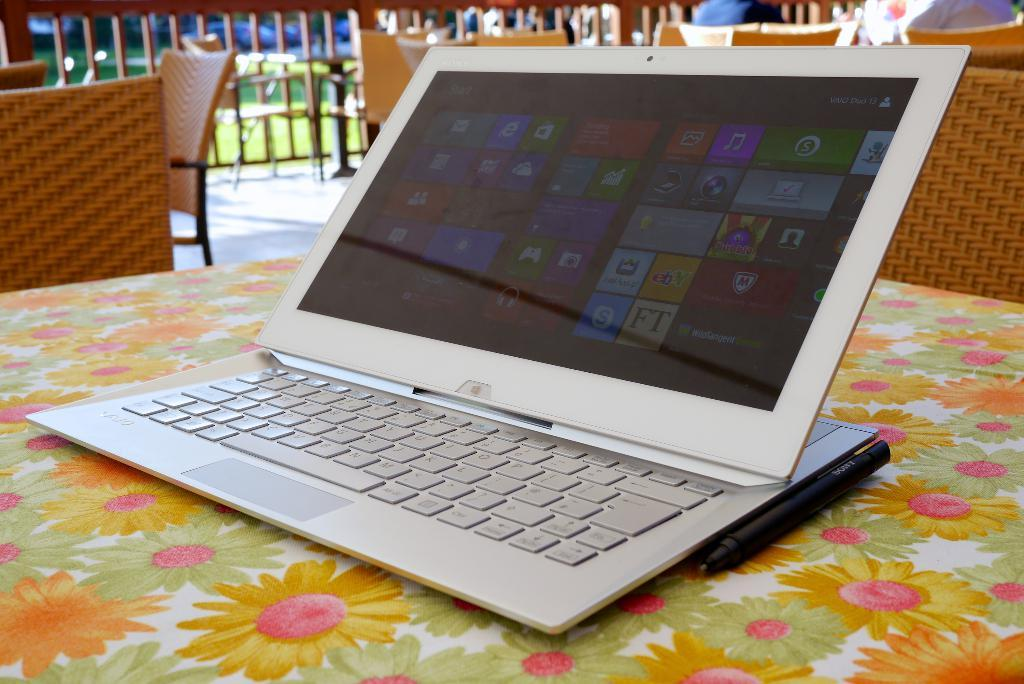What type of furniture is visible in the image? There are tables and chairs in the image. What objects are on the table in the image? A pen and a laptop are on the table in the image. What is the color of the chairs in the image? The chairs in the image are brown in color. Can you tell me where the sink is located in the image? There is no sink present in the image. Is there a cart visible in the image? There is no cart present in the image. 